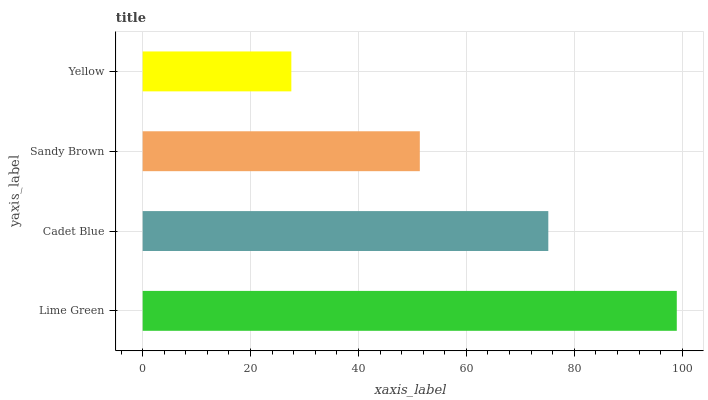Is Yellow the minimum?
Answer yes or no. Yes. Is Lime Green the maximum?
Answer yes or no. Yes. Is Cadet Blue the minimum?
Answer yes or no. No. Is Cadet Blue the maximum?
Answer yes or no. No. Is Lime Green greater than Cadet Blue?
Answer yes or no. Yes. Is Cadet Blue less than Lime Green?
Answer yes or no. Yes. Is Cadet Blue greater than Lime Green?
Answer yes or no. No. Is Lime Green less than Cadet Blue?
Answer yes or no. No. Is Cadet Blue the high median?
Answer yes or no. Yes. Is Sandy Brown the low median?
Answer yes or no. Yes. Is Sandy Brown the high median?
Answer yes or no. No. Is Yellow the low median?
Answer yes or no. No. 